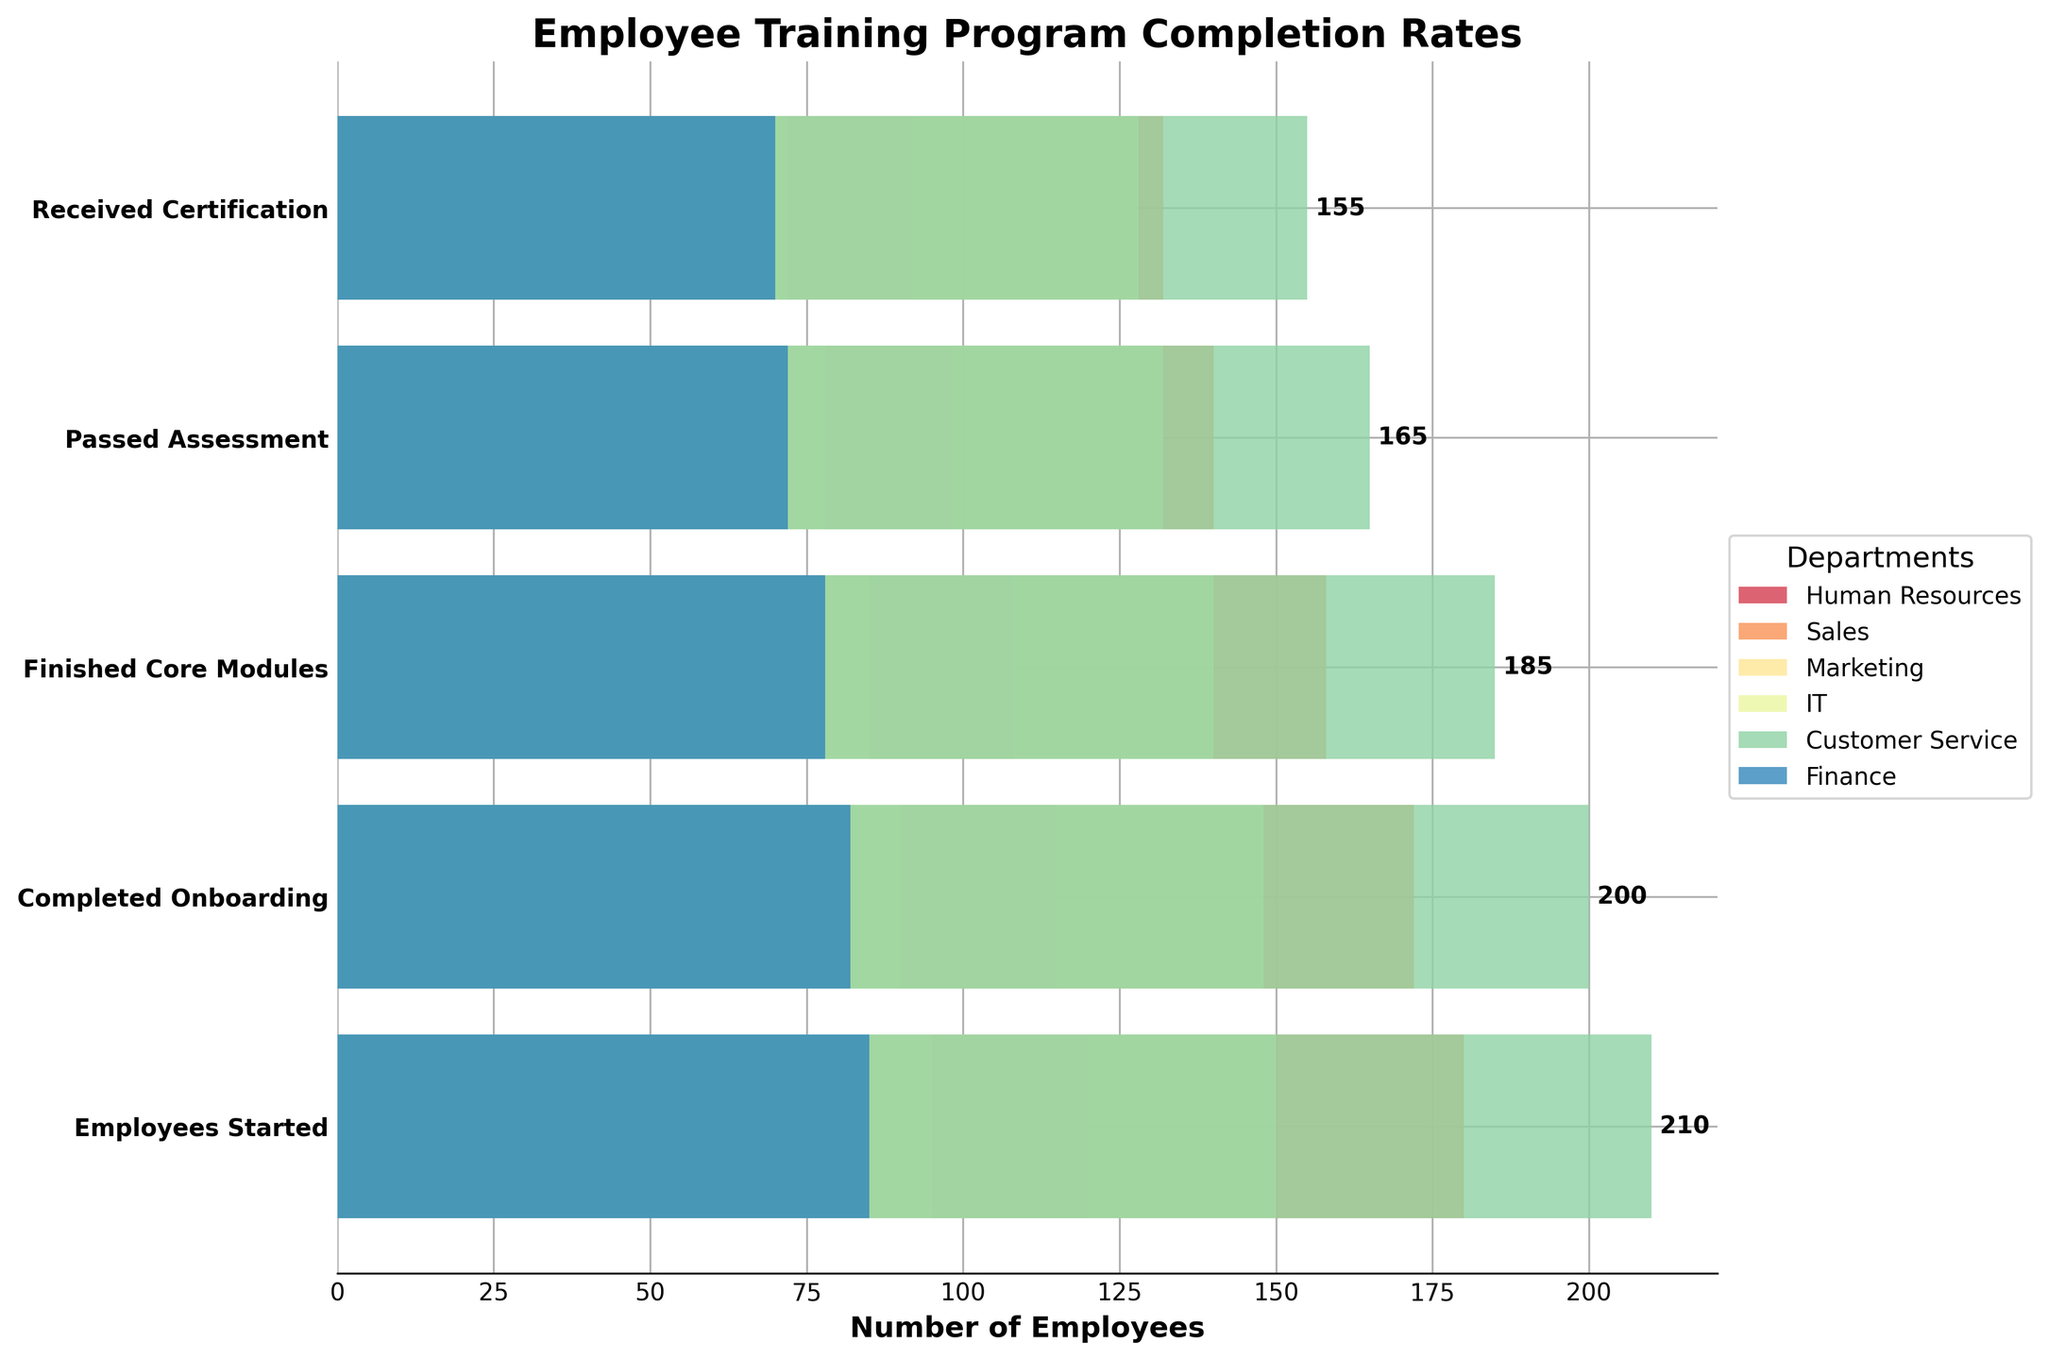What's the title of the funnel chart? The title is typically displayed at the top of the figure to indicate what data the chart represents. In this case, the title should be examined directly from the plot.
Answer: Employee Training Program Completion Rates Which department has the highest number of employees that started the training program? The department with the highest bar in the first stage 'Employees Started' has the most starters. By comparing all departments, Customer Service has the highest value of 210.
Answer: Customer Service What is the number of employees who received certification in the Marketing department? Locate the 'Marketing' department and observe the value at the final stage 'Received Certification.' The number indicated is 72.
Answer: 72 Which department has the lowest completion rate from 'Employees Started' to 'Received Certification'? Calculate the ratio of 'Received Certification' to 'Employees Started' for each department and compare these ratios to find the smallest one.
Answer: Marketing What is the average number of employees who passed the assessment across all departments? Sum the number of employees who passed the assessment in all departments (98 + 140 + 78 + 132 + 165 + 72) and divide by the number of departments (6). The calculation is (685 / 6).
Answer: 114.17 How many more employees completed onboarding in the Sales department than in the Finance department? Subtract the number of completed onboardings in the Finance department from the number in the Sales department (172 - 82).
Answer: 90 Which two departments have an equal number of employees who received certification? Compare the 'Received Certification' values for all departments and look for matches. Finance (70) matches no other department.
Answer: None In which stage does the IT department have the highest drop-off in employee numbers? Look at the drop-off between stages for the IT department and find where the difference between two stages is the largest. The largest drop is between 'Finished Core Modules' (140) and 'Passed Assessment' (132) with a drop-off of 8 employees.
Answer: From 'Finished Core Modules' to 'Passed Assessment' What percentage of employees in the Human Resources department received certification after starting the training? Calculate the ratio of 'Received Certification' to 'Employees Started' and then convert it to a percentage for the Human Resources department (92/120 * 100).
Answer: 76.67% 